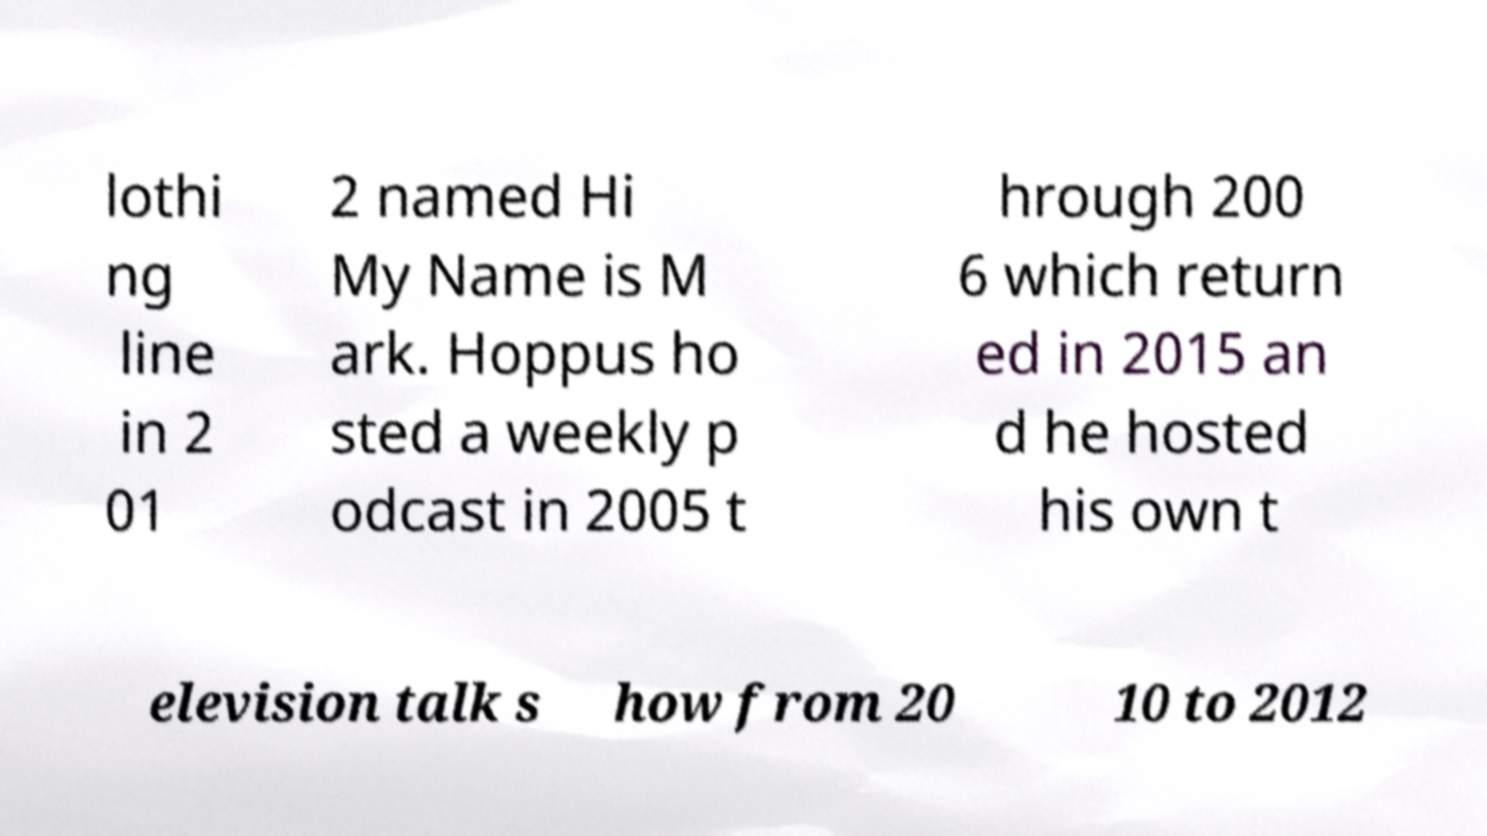Could you extract and type out the text from this image? lothi ng line in 2 01 2 named Hi My Name is M ark. Hoppus ho sted a weekly p odcast in 2005 t hrough 200 6 which return ed in 2015 an d he hosted his own t elevision talk s how from 20 10 to 2012 